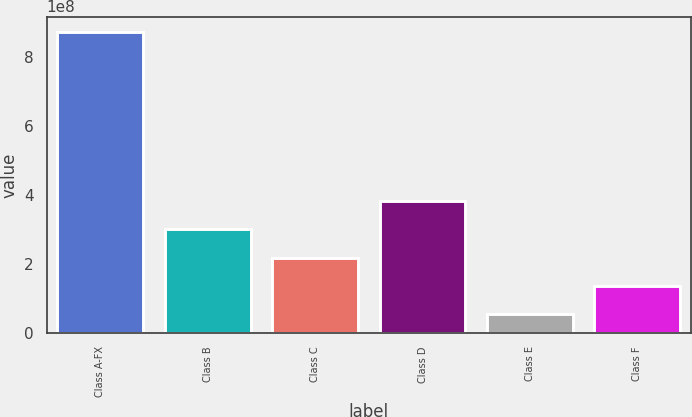<chart> <loc_0><loc_0><loc_500><loc_500><bar_chart><fcel>Class A-FX<fcel>Class B<fcel>Class C<fcel>Class D<fcel>Class E<fcel>Class F<nl><fcel>8.72e+08<fcel>3.001e+08<fcel>2.184e+08<fcel>3.818e+08<fcel>5.5e+07<fcel>1.367e+08<nl></chart> 